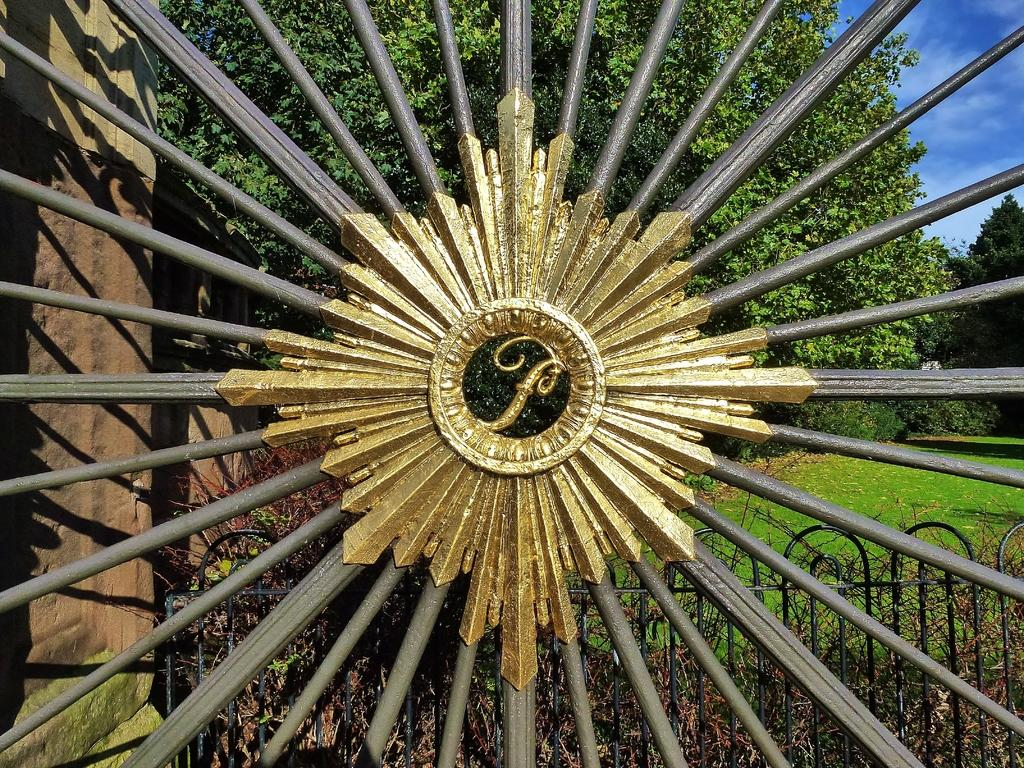What type of material is used for the rods in the image? The rods in the image are made of metal. What structure is visible in the image? There is a fence in the image. What type of vegetation is present in the image? There is grass in the image. What type of structure is visible in the background? There is a building wall in the image. What type of natural elements are visible in the image? There are trees in the image. What part of the natural environment is visible in the image? The sky is visible in the image. Where might this image have been taken? The image may have been taken in a park, given the presence of grass, trees, and a fence. What type of veil is draped over the trees in the image? There is no veil present in the image; it features metal rods, a fence, grass, a building wall, trees, and the sky. What type of creature can be seen climbing the metal rods in the image? There are no creatures visible in the image; it only features metal rods, a fence, grass, a building wall, trees, and the sky. 